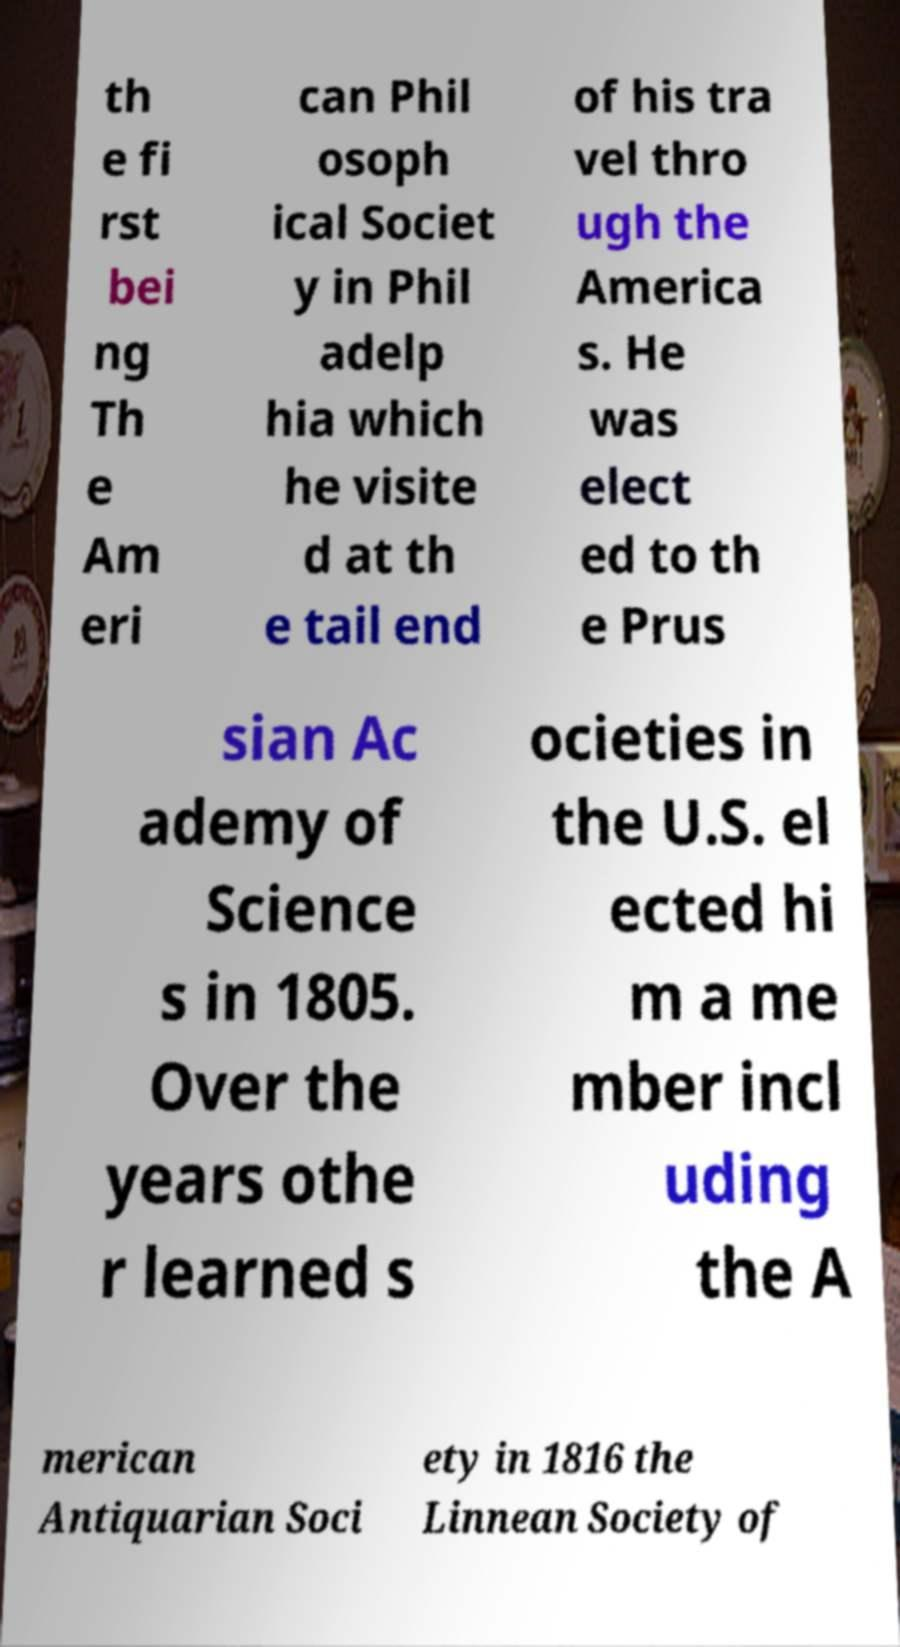I need the written content from this picture converted into text. Can you do that? th e fi rst bei ng Th e Am eri can Phil osoph ical Societ y in Phil adelp hia which he visite d at th e tail end of his tra vel thro ugh the America s. He was elect ed to th e Prus sian Ac ademy of Science s in 1805. Over the years othe r learned s ocieties in the U.S. el ected hi m a me mber incl uding the A merican Antiquarian Soci ety in 1816 the Linnean Society of 